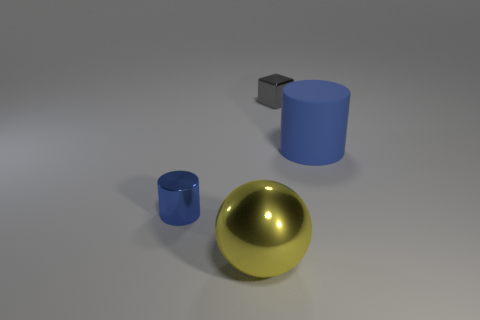What number of other objects are there of the same color as the tiny cylinder?
Ensure brevity in your answer.  1. How many blue things are either tiny shiny cubes or metal cylinders?
Make the answer very short. 1. Is the shape of the large rubber object the same as the object to the left of the large yellow ball?
Provide a succinct answer. Yes. The big matte thing is what shape?
Provide a succinct answer. Cylinder. What is the material of the thing that is the same size as the yellow metal ball?
Keep it short and to the point. Rubber. What number of things are either small blue cylinders or blue things that are in front of the blue rubber object?
Your response must be concise. 1. There is a yellow object that is made of the same material as the tiny gray thing; what is its size?
Provide a short and direct response. Large. The small metal object behind the cylinder on the left side of the large rubber thing is what shape?
Ensure brevity in your answer.  Cube. There is a object that is in front of the small gray thing and right of the yellow ball; how big is it?
Your answer should be very brief. Large. Is there another metal object that has the same shape as the small gray object?
Make the answer very short. No. 